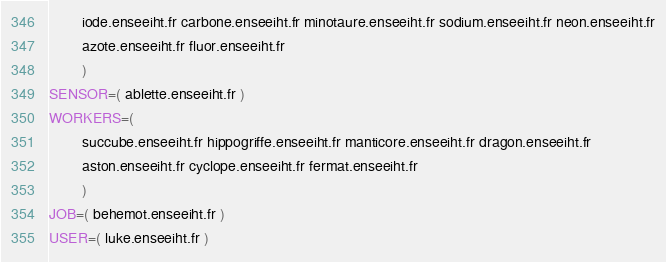Convert code to text. <code><loc_0><loc_0><loc_500><loc_500><_Bash_>        iode.enseeiht.fr carbone.enseeiht.fr minotaure.enseeiht.fr sodium.enseeiht.fr neon.enseeiht.fr
        azote.enseeiht.fr fluor.enseeiht.fr
        )
SENSOR=( ablette.enseeiht.fr )
WORKERS=(
        succube.enseeiht.fr hippogriffe.enseeiht.fr manticore.enseeiht.fr dragon.enseeiht.fr
        aston.enseeiht.fr cyclope.enseeiht.fr fermat.enseeiht.fr
        )
JOB=( behemot.enseeiht.fr )
USER=( luke.enseeiht.fr )
</code> 